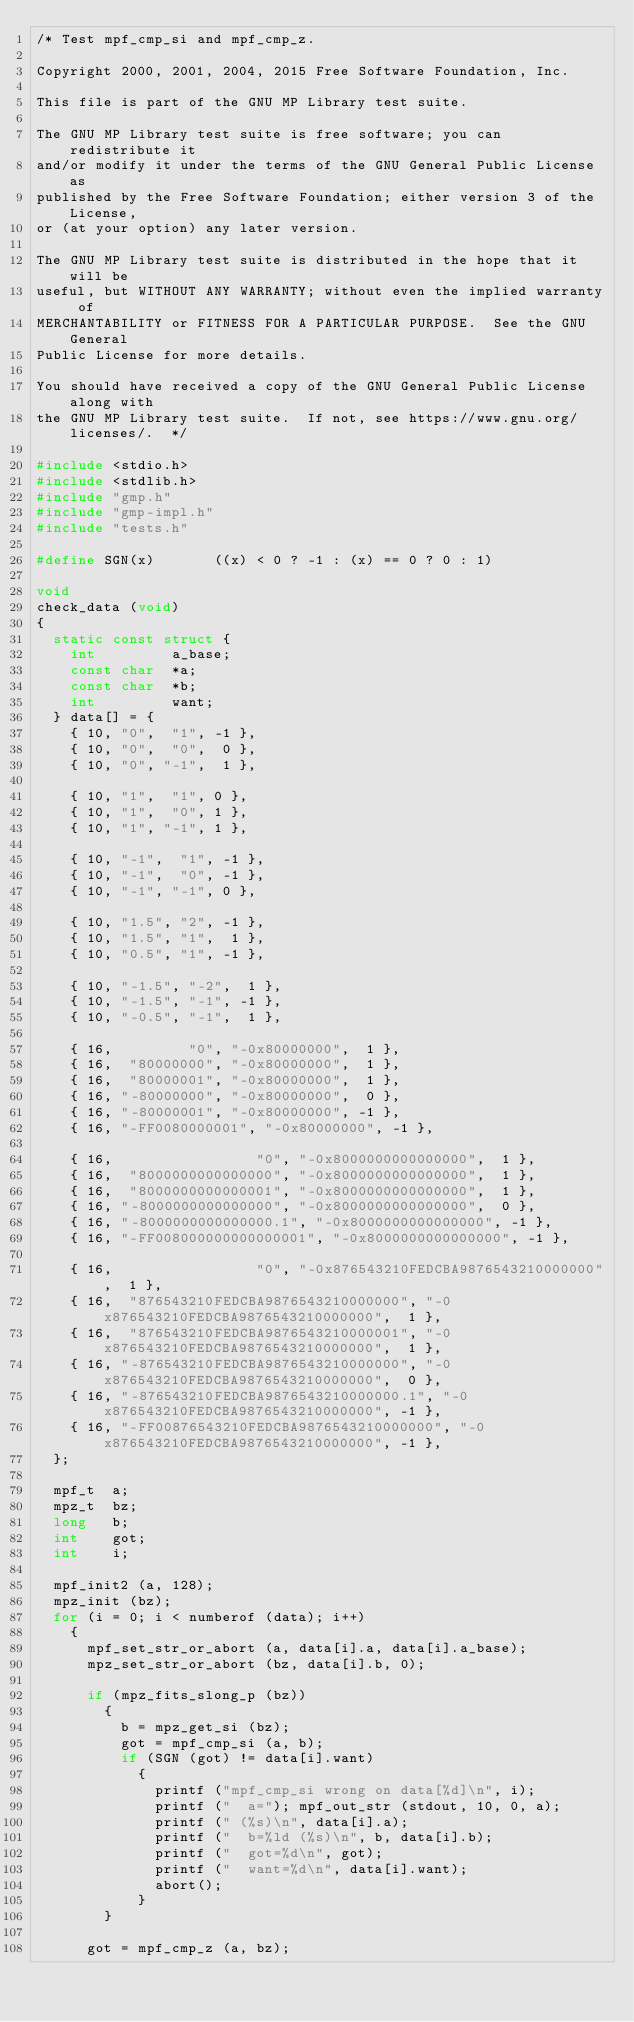<code> <loc_0><loc_0><loc_500><loc_500><_C_>/* Test mpf_cmp_si and mpf_cmp_z.

Copyright 2000, 2001, 2004, 2015 Free Software Foundation, Inc.

This file is part of the GNU MP Library test suite.

The GNU MP Library test suite is free software; you can redistribute it
and/or modify it under the terms of the GNU General Public License as
published by the Free Software Foundation; either version 3 of the License,
or (at your option) any later version.

The GNU MP Library test suite is distributed in the hope that it will be
useful, but WITHOUT ANY WARRANTY; without even the implied warranty of
MERCHANTABILITY or FITNESS FOR A PARTICULAR PURPOSE.  See the GNU General
Public License for more details.

You should have received a copy of the GNU General Public License along with
the GNU MP Library test suite.  If not, see https://www.gnu.org/licenses/.  */

#include <stdio.h>
#include <stdlib.h>
#include "gmp.h"
#include "gmp-impl.h"
#include "tests.h"

#define SGN(x)       ((x) < 0 ? -1 : (x) == 0 ? 0 : 1)

void
check_data (void)
{
  static const struct {
    int         a_base;
    const char  *a;
    const char  *b;
    int         want;
  } data[] = {
    { 10, "0",  "1", -1 },
    { 10, "0",  "0",  0 },
    { 10, "0", "-1",  1 },

    { 10, "1",  "1", 0 },
    { 10, "1",  "0", 1 },
    { 10, "1", "-1", 1 },

    { 10, "-1",  "1", -1 },
    { 10, "-1",  "0", -1 },
    { 10, "-1", "-1", 0 },

    { 10, "1.5", "2", -1 },
    { 10, "1.5", "1",  1 },
    { 10, "0.5", "1", -1 },

    { 10, "-1.5", "-2",  1 },
    { 10, "-1.5", "-1", -1 },
    { 10, "-0.5", "-1",  1 },

    { 16,         "0", "-0x80000000",  1 },
    { 16,  "80000000", "-0x80000000",  1 },
    { 16,  "80000001", "-0x80000000",  1 },
    { 16, "-80000000", "-0x80000000",  0 },
    { 16, "-80000001", "-0x80000000", -1 },
    { 16, "-FF0080000001", "-0x80000000", -1 },

    { 16,                 "0", "-0x8000000000000000",  1 },
    { 16,  "8000000000000000", "-0x8000000000000000",  1 },
    { 16,  "8000000000000001", "-0x8000000000000000",  1 },
    { 16, "-8000000000000000", "-0x8000000000000000",  0 },
    { 16, "-8000000000000000.1", "-0x8000000000000000", -1 },
    { 16, "-FF008000000000000001", "-0x8000000000000000", -1 },

    { 16,                 "0", "-0x876543210FEDCBA9876543210000000",  1 },
    { 16,  "876543210FEDCBA9876543210000000", "-0x876543210FEDCBA9876543210000000",  1 },
    { 16,  "876543210FEDCBA9876543210000001", "-0x876543210FEDCBA9876543210000000",  1 },
    { 16, "-876543210FEDCBA9876543210000000", "-0x876543210FEDCBA9876543210000000",  0 },
    { 16, "-876543210FEDCBA9876543210000000.1", "-0x876543210FEDCBA9876543210000000", -1 },
    { 16, "-FF00876543210FEDCBA9876543210000000", "-0x876543210FEDCBA9876543210000000", -1 },
  };

  mpf_t  a;
  mpz_t  bz;
  long   b;
  int    got;
  int    i;

  mpf_init2 (a, 128);
  mpz_init (bz);
  for (i = 0; i < numberof (data); i++)
    {
      mpf_set_str_or_abort (a, data[i].a, data[i].a_base);
      mpz_set_str_or_abort (bz, data[i].b, 0);

      if (mpz_fits_slong_p (bz))
        {
          b = mpz_get_si (bz);
          got = mpf_cmp_si (a, b);
          if (SGN (got) != data[i].want)
            {
              printf ("mpf_cmp_si wrong on data[%d]\n", i);
              printf ("  a="); mpf_out_str (stdout, 10, 0, a);
              printf (" (%s)\n", data[i].a);
              printf ("  b=%ld (%s)\n", b, data[i].b);
              printf ("  got=%d\n", got);
              printf ("  want=%d\n", data[i].want);
              abort();
            }
        }

      got = mpf_cmp_z (a, bz);</code> 